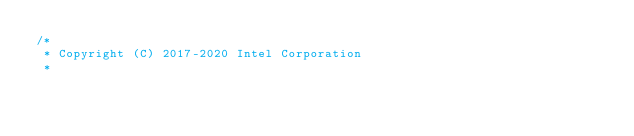<code> <loc_0><loc_0><loc_500><loc_500><_C++_>/*
 * Copyright (C) 2017-2020 Intel Corporation
 *</code> 